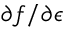Convert formula to latex. <formula><loc_0><loc_0><loc_500><loc_500>\partial f / \partial \epsilon</formula> 